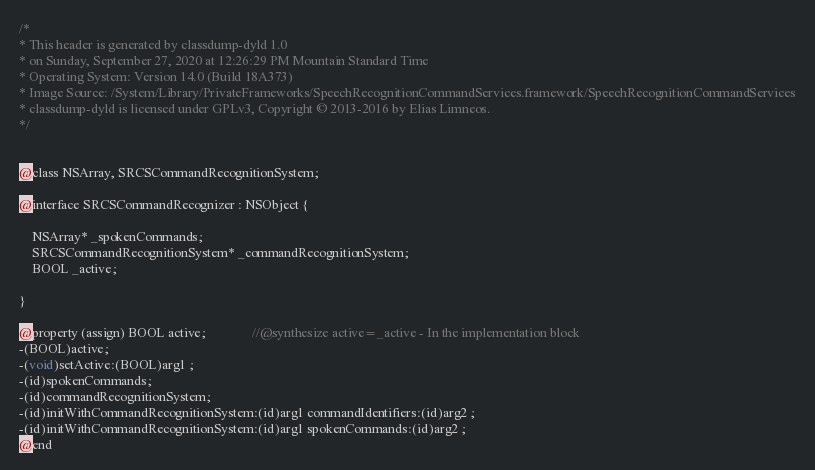<code> <loc_0><loc_0><loc_500><loc_500><_C_>/*
* This header is generated by classdump-dyld 1.0
* on Sunday, September 27, 2020 at 12:26:29 PM Mountain Standard Time
* Operating System: Version 14.0 (Build 18A373)
* Image Source: /System/Library/PrivateFrameworks/SpeechRecognitionCommandServices.framework/SpeechRecognitionCommandServices
* classdump-dyld is licensed under GPLv3, Copyright © 2013-2016 by Elias Limneos.
*/


@class NSArray, SRCSCommandRecognitionSystem;

@interface SRCSCommandRecognizer : NSObject {

	NSArray* _spokenCommands;
	SRCSCommandRecognitionSystem* _commandRecognitionSystem;
	BOOL _active;

}

@property (assign) BOOL active;              //@synthesize active=_active - In the implementation block
-(BOOL)active;
-(void)setActive:(BOOL)arg1 ;
-(id)spokenCommands;
-(id)commandRecognitionSystem;
-(id)initWithCommandRecognitionSystem:(id)arg1 commandIdentifiers:(id)arg2 ;
-(id)initWithCommandRecognitionSystem:(id)arg1 spokenCommands:(id)arg2 ;
@end

</code> 